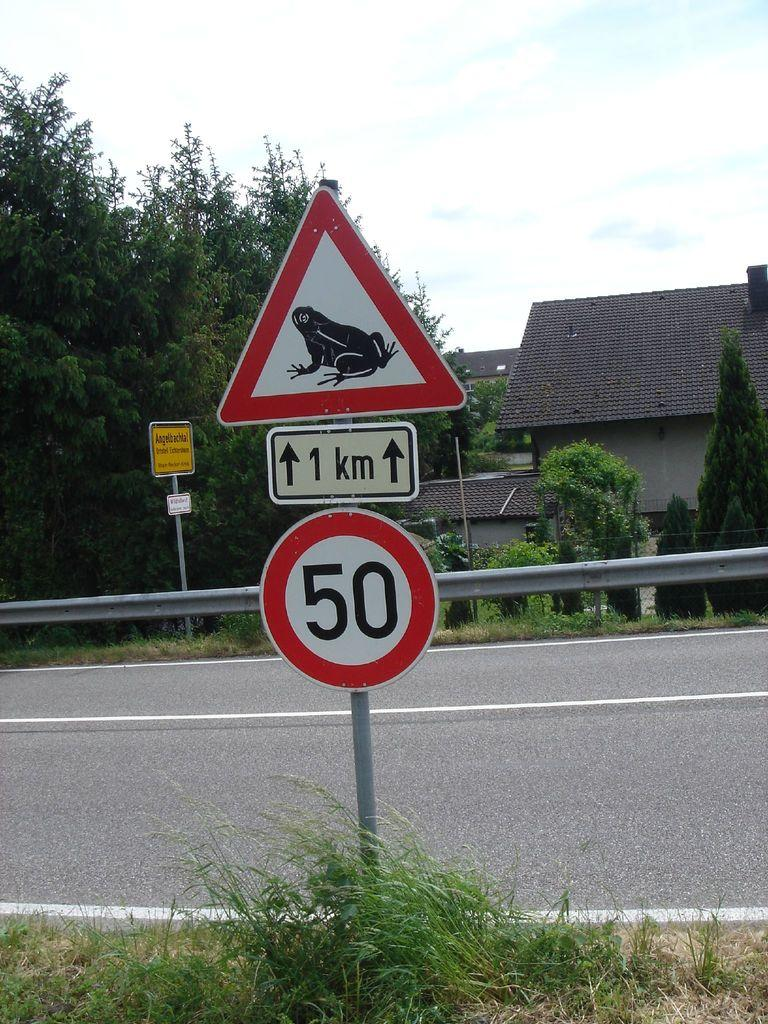<image>
Share a concise interpretation of the image provided. A triangular caution sign with a frog on it with a 1KM and 50 sign under it. 